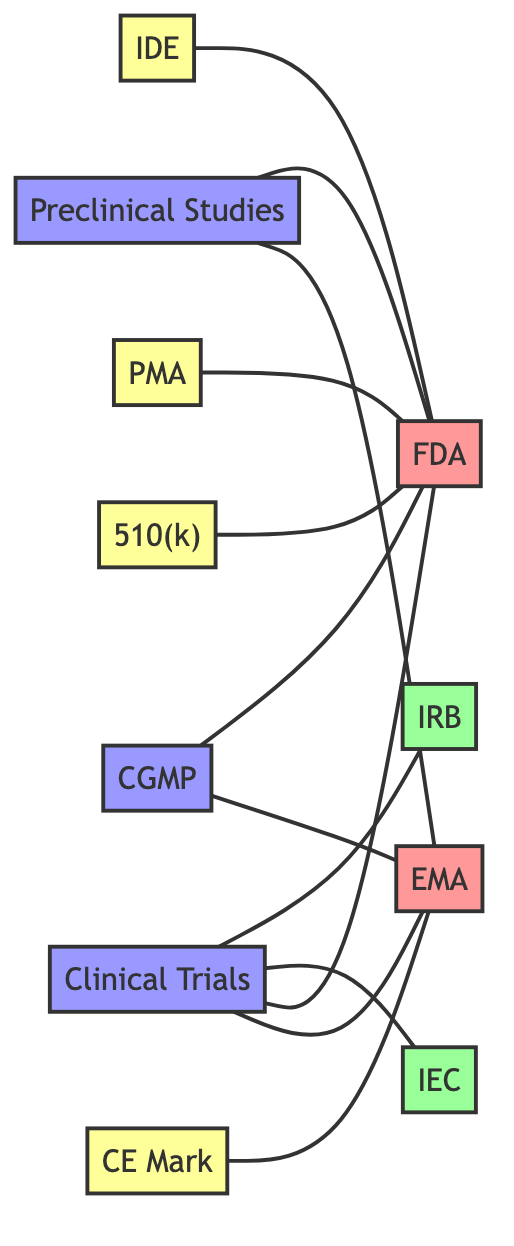What is the total number of nodes in the diagram? The diagram has a total of 11 nodes listed: FDA, EMA, IRB, IEC, Preclinical Studies, Clinical Trials, IDE, PMA, CE Mark, 510(k), and CGMP. Therefore, when counted, the total is 11.
Answer: 11 Which regulatory body is associated with the CE Marking? The CE Marking is connected to the European Medicines Agency (EMA), as denoted by the edge linking CE Mark to EMA with the relationship labeled "certification."
Answer: EMA What type of review is associated with Preclinical Studies? Preclinical Studies are associated with a review process conducted by the FDA and EMA. The edges show both regulatory bodies linked to Preclinical Studies with the relationship labeled "review."
Answer: review How many approval processes are connected to the FDA? The FDA is linked to four approval processes: IDE, PMA, 510(k), and Clinical Trials. Each connection indicates that these processes require an application to the FDA.
Answer: 4 Which two bodies provide approval for Clinical Trials? The Institutional Review Board (IRB) and the Independent Ethics Committee (IEC) are directly connected to Clinical Trials, both represented as approval entities in the diagram.
Answer: IRB and IEC What relationship connects the CGMP to regulatory bodies? The Current Good Manufacturing Practice (CGMP) is connected to both the FDA and EMA with the relationship labeled "compliance," indicating that both bodies require adherence to these standards.
Answer: compliance Which phase directly precedes Clinical Trials in the product development process? The Preclinical Studies phase comes directly before Clinical Trials, as indicated by the edges showing a relationship from Preclinical to Clinical Trials.
Answer: Preclinical Studies What is the primary difference between Premarket Approval and 510(k) clearance? While both are applications made to the FDA, PMA is a more rigorous process compared to the 510(k) clearance, which is typically faster and for devices that are substantially equivalent to existing products.
Answer: rigorous (for PMA) and faster (for 510k) In this diagram, which ethical review body is not connected to FDA? The Independent Ethics Committee (IEC) is not directly connected to the FDA, as it is only linked to Clinical Trials. In contrast, the Institutional Review Board (IRB) is connected to Clinical Trials and indirectly to the regulatory bodies.
Answer: IEC 